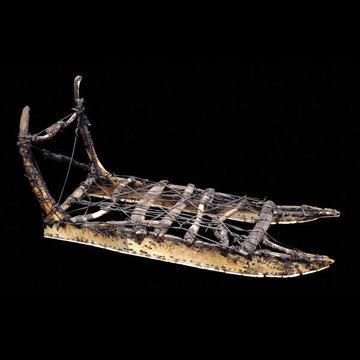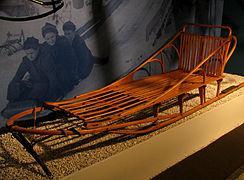The first image is the image on the left, the second image is the image on the right. For the images shown, is this caption "The sled in the left image is facing right." true? Answer yes or no. Yes. 